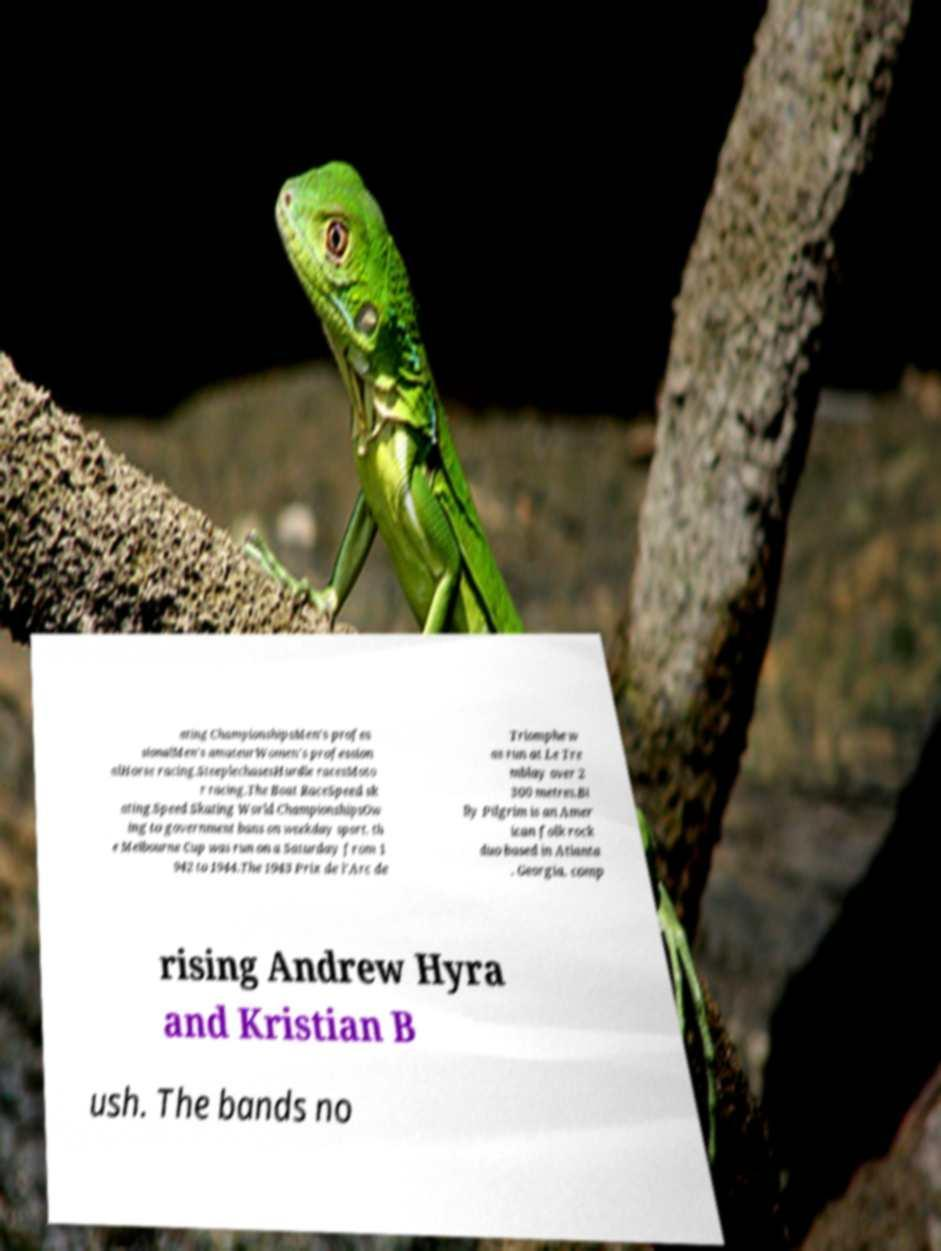Can you accurately transcribe the text from the provided image for me? ating ChampionshipsMen's profes sionalMen's amateurWomen's profession alHorse racing.SteeplechasesHurdle racesMoto r racing.The Boat RaceSpeed sk ating.Speed Skating World ChampionshipsOw ing to government bans on weekday sport, th e Melbourne Cup was run on a Saturday from 1 942 to 1944.The 1943 Prix de l'Arc de Triomphe w as run at Le Tre mblay over 2 300 metres.Bi lly Pilgrim is an Amer ican folk rock duo based in Atlanta , Georgia, comp rising Andrew Hyra and Kristian B ush. The bands no 